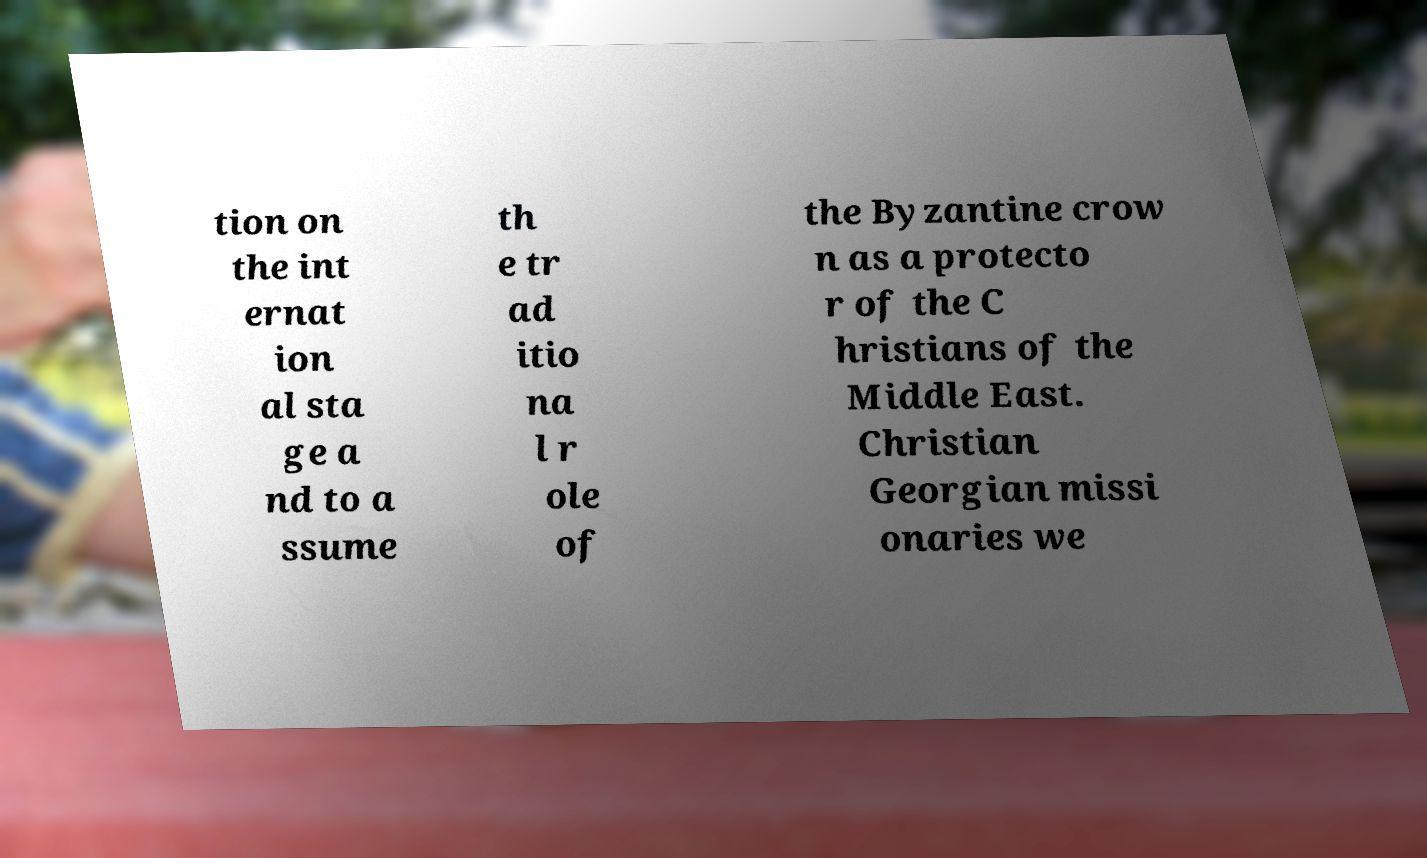I need the written content from this picture converted into text. Can you do that? tion on the int ernat ion al sta ge a nd to a ssume th e tr ad itio na l r ole of the Byzantine crow n as a protecto r of the C hristians of the Middle East. Christian Georgian missi onaries we 